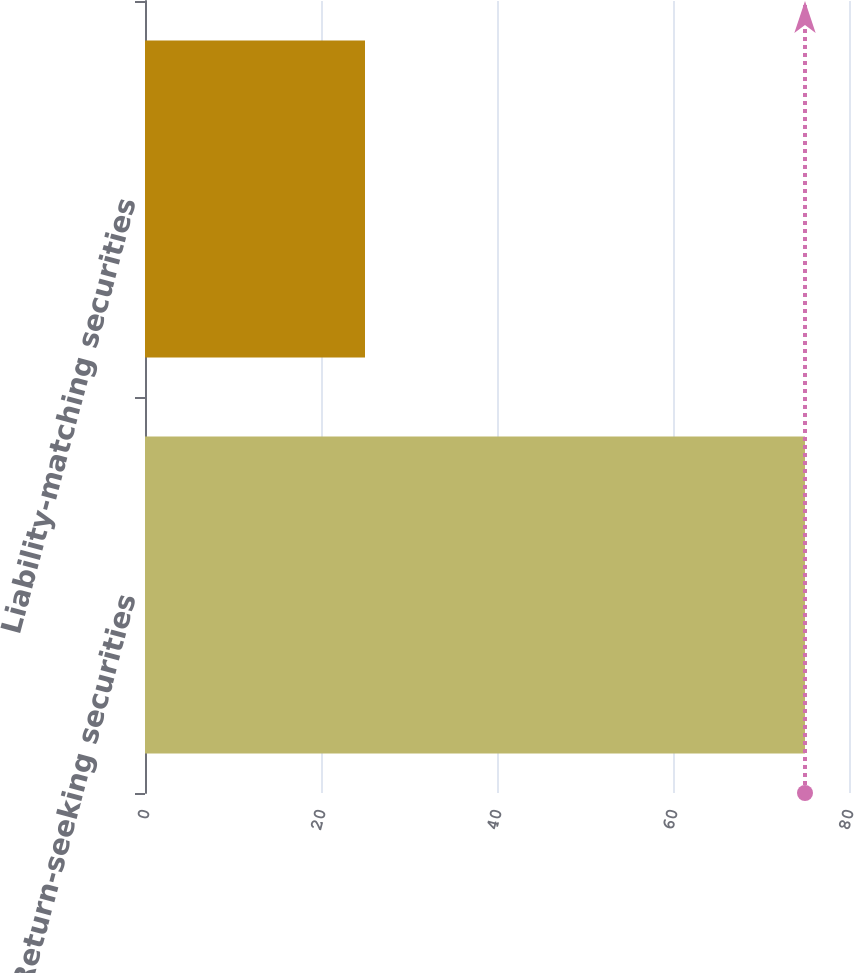Convert chart to OTSL. <chart><loc_0><loc_0><loc_500><loc_500><bar_chart><fcel>Return-seeking securities<fcel>Liability-matching securities<nl><fcel>75<fcel>25<nl></chart> 